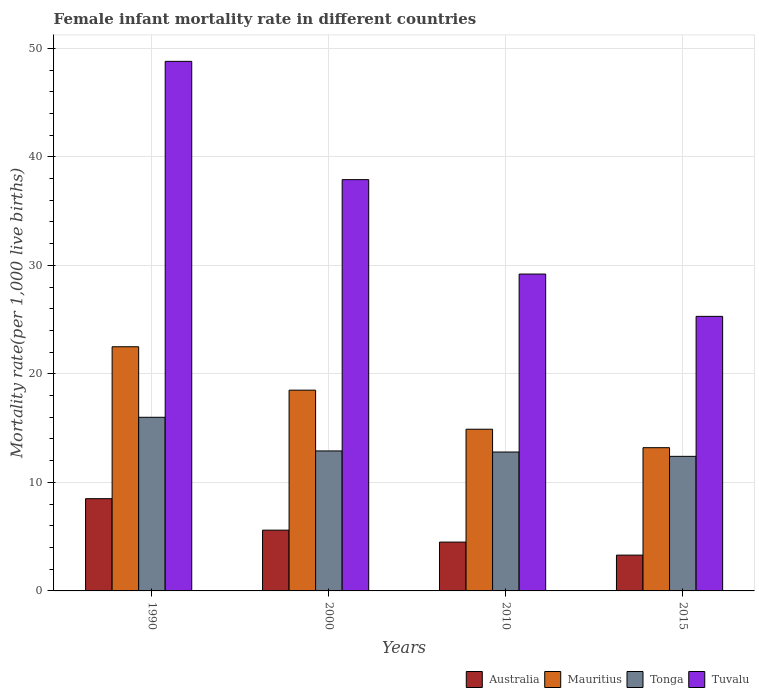How many different coloured bars are there?
Your answer should be compact. 4. How many groups of bars are there?
Offer a terse response. 4. How many bars are there on the 2nd tick from the right?
Give a very brief answer. 4. Across all years, what is the maximum female infant mortality rate in Tuvalu?
Give a very brief answer. 48.8. Across all years, what is the minimum female infant mortality rate in Tuvalu?
Your response must be concise. 25.3. In which year was the female infant mortality rate in Mauritius minimum?
Give a very brief answer. 2015. What is the total female infant mortality rate in Tuvalu in the graph?
Your response must be concise. 141.2. What is the difference between the female infant mortality rate in Australia in 1990 and that in 2000?
Give a very brief answer. 2.9. What is the difference between the female infant mortality rate in Australia in 2000 and the female infant mortality rate in Tuvalu in 1990?
Give a very brief answer. -43.2. What is the average female infant mortality rate in Mauritius per year?
Your answer should be very brief. 17.27. In how many years, is the female infant mortality rate in Tonga greater than 34?
Keep it short and to the point. 0. What is the ratio of the female infant mortality rate in Tuvalu in 2000 to that in 2010?
Keep it short and to the point. 1.3. Is the difference between the female infant mortality rate in Tuvalu in 1990 and 2010 greater than the difference between the female infant mortality rate in Mauritius in 1990 and 2010?
Make the answer very short. Yes. What is the difference between the highest and the lowest female infant mortality rate in Mauritius?
Ensure brevity in your answer.  9.3. In how many years, is the female infant mortality rate in Australia greater than the average female infant mortality rate in Australia taken over all years?
Offer a terse response. 2. What does the 4th bar from the left in 2010 represents?
Give a very brief answer. Tuvalu. What does the 1st bar from the right in 2015 represents?
Keep it short and to the point. Tuvalu. Is it the case that in every year, the sum of the female infant mortality rate in Tuvalu and female infant mortality rate in Australia is greater than the female infant mortality rate in Tonga?
Your response must be concise. Yes. How many bars are there?
Offer a very short reply. 16. What is the difference between two consecutive major ticks on the Y-axis?
Give a very brief answer. 10. Are the values on the major ticks of Y-axis written in scientific E-notation?
Offer a very short reply. No. Does the graph contain grids?
Provide a succinct answer. Yes. Where does the legend appear in the graph?
Give a very brief answer. Bottom right. How many legend labels are there?
Your response must be concise. 4. How are the legend labels stacked?
Make the answer very short. Horizontal. What is the title of the graph?
Provide a short and direct response. Female infant mortality rate in different countries. Does "Congo (Democratic)" appear as one of the legend labels in the graph?
Make the answer very short. No. What is the label or title of the Y-axis?
Keep it short and to the point. Mortality rate(per 1,0 live births). What is the Mortality rate(per 1,000 live births) of Australia in 1990?
Keep it short and to the point. 8.5. What is the Mortality rate(per 1,000 live births) of Tonga in 1990?
Your answer should be compact. 16. What is the Mortality rate(per 1,000 live births) of Tuvalu in 1990?
Offer a very short reply. 48.8. What is the Mortality rate(per 1,000 live births) in Australia in 2000?
Keep it short and to the point. 5.6. What is the Mortality rate(per 1,000 live births) of Tuvalu in 2000?
Your answer should be compact. 37.9. What is the Mortality rate(per 1,000 live births) in Tonga in 2010?
Make the answer very short. 12.8. What is the Mortality rate(per 1,000 live births) of Tuvalu in 2010?
Keep it short and to the point. 29.2. What is the Mortality rate(per 1,000 live births) in Australia in 2015?
Ensure brevity in your answer.  3.3. What is the Mortality rate(per 1,000 live births) of Tonga in 2015?
Ensure brevity in your answer.  12.4. What is the Mortality rate(per 1,000 live births) of Tuvalu in 2015?
Ensure brevity in your answer.  25.3. Across all years, what is the maximum Mortality rate(per 1,000 live births) in Tuvalu?
Offer a very short reply. 48.8. Across all years, what is the minimum Mortality rate(per 1,000 live births) in Australia?
Your answer should be compact. 3.3. Across all years, what is the minimum Mortality rate(per 1,000 live births) in Tuvalu?
Give a very brief answer. 25.3. What is the total Mortality rate(per 1,000 live births) of Australia in the graph?
Offer a very short reply. 21.9. What is the total Mortality rate(per 1,000 live births) in Mauritius in the graph?
Offer a very short reply. 69.1. What is the total Mortality rate(per 1,000 live births) of Tonga in the graph?
Your response must be concise. 54.1. What is the total Mortality rate(per 1,000 live births) in Tuvalu in the graph?
Your answer should be very brief. 141.2. What is the difference between the Mortality rate(per 1,000 live births) in Australia in 1990 and that in 2000?
Your response must be concise. 2.9. What is the difference between the Mortality rate(per 1,000 live births) of Mauritius in 1990 and that in 2000?
Your answer should be compact. 4. What is the difference between the Mortality rate(per 1,000 live births) in Tonga in 1990 and that in 2000?
Your answer should be compact. 3.1. What is the difference between the Mortality rate(per 1,000 live births) of Australia in 1990 and that in 2010?
Your response must be concise. 4. What is the difference between the Mortality rate(per 1,000 live births) of Tuvalu in 1990 and that in 2010?
Your response must be concise. 19.6. What is the difference between the Mortality rate(per 1,000 live births) in Australia in 1990 and that in 2015?
Your answer should be compact. 5.2. What is the difference between the Mortality rate(per 1,000 live births) of Tuvalu in 1990 and that in 2015?
Your answer should be compact. 23.5. What is the difference between the Mortality rate(per 1,000 live births) in Australia in 2000 and that in 2010?
Provide a short and direct response. 1.1. What is the difference between the Mortality rate(per 1,000 live births) of Australia in 2000 and that in 2015?
Keep it short and to the point. 2.3. What is the difference between the Mortality rate(per 1,000 live births) of Mauritius in 2000 and that in 2015?
Offer a terse response. 5.3. What is the difference between the Mortality rate(per 1,000 live births) of Tonga in 2000 and that in 2015?
Make the answer very short. 0.5. What is the difference between the Mortality rate(per 1,000 live births) in Tonga in 2010 and that in 2015?
Offer a terse response. 0.4. What is the difference between the Mortality rate(per 1,000 live births) in Tuvalu in 2010 and that in 2015?
Provide a short and direct response. 3.9. What is the difference between the Mortality rate(per 1,000 live births) of Australia in 1990 and the Mortality rate(per 1,000 live births) of Mauritius in 2000?
Give a very brief answer. -10. What is the difference between the Mortality rate(per 1,000 live births) of Australia in 1990 and the Mortality rate(per 1,000 live births) of Tuvalu in 2000?
Give a very brief answer. -29.4. What is the difference between the Mortality rate(per 1,000 live births) in Mauritius in 1990 and the Mortality rate(per 1,000 live births) in Tonga in 2000?
Give a very brief answer. 9.6. What is the difference between the Mortality rate(per 1,000 live births) in Mauritius in 1990 and the Mortality rate(per 1,000 live births) in Tuvalu in 2000?
Keep it short and to the point. -15.4. What is the difference between the Mortality rate(per 1,000 live births) in Tonga in 1990 and the Mortality rate(per 1,000 live births) in Tuvalu in 2000?
Give a very brief answer. -21.9. What is the difference between the Mortality rate(per 1,000 live births) of Australia in 1990 and the Mortality rate(per 1,000 live births) of Tuvalu in 2010?
Your answer should be compact. -20.7. What is the difference between the Mortality rate(per 1,000 live births) in Mauritius in 1990 and the Mortality rate(per 1,000 live births) in Tonga in 2010?
Offer a terse response. 9.7. What is the difference between the Mortality rate(per 1,000 live births) of Tonga in 1990 and the Mortality rate(per 1,000 live births) of Tuvalu in 2010?
Provide a short and direct response. -13.2. What is the difference between the Mortality rate(per 1,000 live births) of Australia in 1990 and the Mortality rate(per 1,000 live births) of Tuvalu in 2015?
Your response must be concise. -16.8. What is the difference between the Mortality rate(per 1,000 live births) of Australia in 2000 and the Mortality rate(per 1,000 live births) of Mauritius in 2010?
Ensure brevity in your answer.  -9.3. What is the difference between the Mortality rate(per 1,000 live births) of Australia in 2000 and the Mortality rate(per 1,000 live births) of Tonga in 2010?
Give a very brief answer. -7.2. What is the difference between the Mortality rate(per 1,000 live births) of Australia in 2000 and the Mortality rate(per 1,000 live births) of Tuvalu in 2010?
Offer a terse response. -23.6. What is the difference between the Mortality rate(per 1,000 live births) in Mauritius in 2000 and the Mortality rate(per 1,000 live births) in Tuvalu in 2010?
Make the answer very short. -10.7. What is the difference between the Mortality rate(per 1,000 live births) of Tonga in 2000 and the Mortality rate(per 1,000 live births) of Tuvalu in 2010?
Provide a short and direct response. -16.3. What is the difference between the Mortality rate(per 1,000 live births) of Australia in 2000 and the Mortality rate(per 1,000 live births) of Tuvalu in 2015?
Ensure brevity in your answer.  -19.7. What is the difference between the Mortality rate(per 1,000 live births) of Mauritius in 2000 and the Mortality rate(per 1,000 live births) of Tuvalu in 2015?
Offer a terse response. -6.8. What is the difference between the Mortality rate(per 1,000 live births) in Australia in 2010 and the Mortality rate(per 1,000 live births) in Mauritius in 2015?
Make the answer very short. -8.7. What is the difference between the Mortality rate(per 1,000 live births) of Australia in 2010 and the Mortality rate(per 1,000 live births) of Tuvalu in 2015?
Keep it short and to the point. -20.8. What is the difference between the Mortality rate(per 1,000 live births) of Mauritius in 2010 and the Mortality rate(per 1,000 live births) of Tuvalu in 2015?
Provide a short and direct response. -10.4. What is the average Mortality rate(per 1,000 live births) of Australia per year?
Your answer should be very brief. 5.47. What is the average Mortality rate(per 1,000 live births) in Mauritius per year?
Give a very brief answer. 17.27. What is the average Mortality rate(per 1,000 live births) of Tonga per year?
Your response must be concise. 13.53. What is the average Mortality rate(per 1,000 live births) in Tuvalu per year?
Your answer should be compact. 35.3. In the year 1990, what is the difference between the Mortality rate(per 1,000 live births) in Australia and Mortality rate(per 1,000 live births) in Mauritius?
Your answer should be compact. -14. In the year 1990, what is the difference between the Mortality rate(per 1,000 live births) of Australia and Mortality rate(per 1,000 live births) of Tuvalu?
Make the answer very short. -40.3. In the year 1990, what is the difference between the Mortality rate(per 1,000 live births) in Mauritius and Mortality rate(per 1,000 live births) in Tuvalu?
Your answer should be very brief. -26.3. In the year 1990, what is the difference between the Mortality rate(per 1,000 live births) of Tonga and Mortality rate(per 1,000 live births) of Tuvalu?
Provide a short and direct response. -32.8. In the year 2000, what is the difference between the Mortality rate(per 1,000 live births) in Australia and Mortality rate(per 1,000 live births) in Tonga?
Your answer should be compact. -7.3. In the year 2000, what is the difference between the Mortality rate(per 1,000 live births) in Australia and Mortality rate(per 1,000 live births) in Tuvalu?
Your response must be concise. -32.3. In the year 2000, what is the difference between the Mortality rate(per 1,000 live births) of Mauritius and Mortality rate(per 1,000 live births) of Tonga?
Give a very brief answer. 5.6. In the year 2000, what is the difference between the Mortality rate(per 1,000 live births) in Mauritius and Mortality rate(per 1,000 live births) in Tuvalu?
Your answer should be very brief. -19.4. In the year 2000, what is the difference between the Mortality rate(per 1,000 live births) of Tonga and Mortality rate(per 1,000 live births) of Tuvalu?
Provide a short and direct response. -25. In the year 2010, what is the difference between the Mortality rate(per 1,000 live births) in Australia and Mortality rate(per 1,000 live births) in Tonga?
Ensure brevity in your answer.  -8.3. In the year 2010, what is the difference between the Mortality rate(per 1,000 live births) in Australia and Mortality rate(per 1,000 live births) in Tuvalu?
Offer a very short reply. -24.7. In the year 2010, what is the difference between the Mortality rate(per 1,000 live births) in Mauritius and Mortality rate(per 1,000 live births) in Tuvalu?
Make the answer very short. -14.3. In the year 2010, what is the difference between the Mortality rate(per 1,000 live births) in Tonga and Mortality rate(per 1,000 live births) in Tuvalu?
Ensure brevity in your answer.  -16.4. In the year 2015, what is the difference between the Mortality rate(per 1,000 live births) of Australia and Mortality rate(per 1,000 live births) of Mauritius?
Your answer should be compact. -9.9. In the year 2015, what is the difference between the Mortality rate(per 1,000 live births) in Australia and Mortality rate(per 1,000 live births) in Tuvalu?
Offer a very short reply. -22. In the year 2015, what is the difference between the Mortality rate(per 1,000 live births) in Mauritius and Mortality rate(per 1,000 live births) in Tuvalu?
Your answer should be compact. -12.1. In the year 2015, what is the difference between the Mortality rate(per 1,000 live births) of Tonga and Mortality rate(per 1,000 live births) of Tuvalu?
Provide a short and direct response. -12.9. What is the ratio of the Mortality rate(per 1,000 live births) of Australia in 1990 to that in 2000?
Offer a very short reply. 1.52. What is the ratio of the Mortality rate(per 1,000 live births) of Mauritius in 1990 to that in 2000?
Your answer should be very brief. 1.22. What is the ratio of the Mortality rate(per 1,000 live births) of Tonga in 1990 to that in 2000?
Give a very brief answer. 1.24. What is the ratio of the Mortality rate(per 1,000 live births) in Tuvalu in 1990 to that in 2000?
Offer a terse response. 1.29. What is the ratio of the Mortality rate(per 1,000 live births) in Australia in 1990 to that in 2010?
Provide a short and direct response. 1.89. What is the ratio of the Mortality rate(per 1,000 live births) of Mauritius in 1990 to that in 2010?
Offer a very short reply. 1.51. What is the ratio of the Mortality rate(per 1,000 live births) in Tonga in 1990 to that in 2010?
Ensure brevity in your answer.  1.25. What is the ratio of the Mortality rate(per 1,000 live births) in Tuvalu in 1990 to that in 2010?
Keep it short and to the point. 1.67. What is the ratio of the Mortality rate(per 1,000 live births) of Australia in 1990 to that in 2015?
Give a very brief answer. 2.58. What is the ratio of the Mortality rate(per 1,000 live births) of Mauritius in 1990 to that in 2015?
Give a very brief answer. 1.7. What is the ratio of the Mortality rate(per 1,000 live births) of Tonga in 1990 to that in 2015?
Keep it short and to the point. 1.29. What is the ratio of the Mortality rate(per 1,000 live births) of Tuvalu in 1990 to that in 2015?
Your answer should be very brief. 1.93. What is the ratio of the Mortality rate(per 1,000 live births) in Australia in 2000 to that in 2010?
Give a very brief answer. 1.24. What is the ratio of the Mortality rate(per 1,000 live births) of Mauritius in 2000 to that in 2010?
Ensure brevity in your answer.  1.24. What is the ratio of the Mortality rate(per 1,000 live births) of Tuvalu in 2000 to that in 2010?
Keep it short and to the point. 1.3. What is the ratio of the Mortality rate(per 1,000 live births) of Australia in 2000 to that in 2015?
Make the answer very short. 1.7. What is the ratio of the Mortality rate(per 1,000 live births) in Mauritius in 2000 to that in 2015?
Your answer should be compact. 1.4. What is the ratio of the Mortality rate(per 1,000 live births) in Tonga in 2000 to that in 2015?
Make the answer very short. 1.04. What is the ratio of the Mortality rate(per 1,000 live births) of Tuvalu in 2000 to that in 2015?
Your answer should be compact. 1.5. What is the ratio of the Mortality rate(per 1,000 live births) in Australia in 2010 to that in 2015?
Your response must be concise. 1.36. What is the ratio of the Mortality rate(per 1,000 live births) of Mauritius in 2010 to that in 2015?
Ensure brevity in your answer.  1.13. What is the ratio of the Mortality rate(per 1,000 live births) of Tonga in 2010 to that in 2015?
Ensure brevity in your answer.  1.03. What is the ratio of the Mortality rate(per 1,000 live births) of Tuvalu in 2010 to that in 2015?
Keep it short and to the point. 1.15. What is the difference between the highest and the second highest Mortality rate(per 1,000 live births) in Mauritius?
Offer a very short reply. 4. 